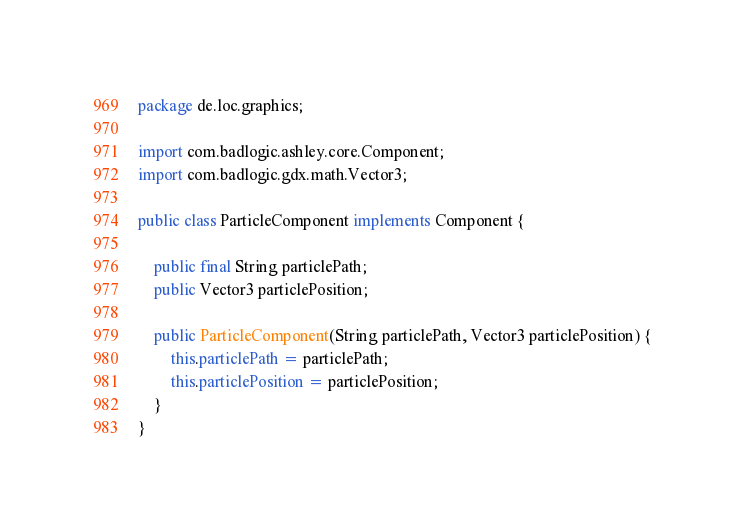<code> <loc_0><loc_0><loc_500><loc_500><_Java_>package de.loc.graphics;

import com.badlogic.ashley.core.Component;
import com.badlogic.gdx.math.Vector3;

public class ParticleComponent implements Component {

    public final String particlePath;
    public Vector3 particlePosition;

    public ParticleComponent(String particlePath, Vector3 particlePosition) {
        this.particlePath = particlePath;
        this.particlePosition = particlePosition;
    }
}
</code> 